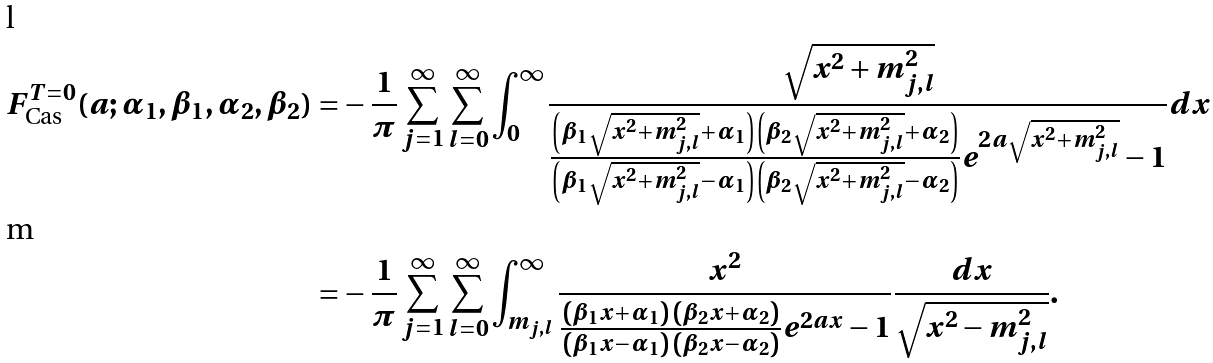Convert formula to latex. <formula><loc_0><loc_0><loc_500><loc_500>F ^ { T = 0 } _ { \text {Cas} } ( a ; \alpha _ { 1 } , \beta _ { 1 } , \alpha _ { 2 } , \beta _ { 2 } ) = & - \frac { 1 } { \pi } \sum _ { j = 1 } ^ { \infty } \sum _ { l = 0 } ^ { \infty } \int _ { 0 } ^ { \infty } \frac { \sqrt { x ^ { 2 } + m _ { j , l } ^ { 2 } } } { \frac { \left ( \beta _ { 1 } \sqrt { x ^ { 2 } + m _ { j , l } ^ { 2 } } + \alpha _ { 1 } \right ) \left ( \beta _ { 2 } \sqrt { x ^ { 2 } + m _ { j , l } ^ { 2 } } + \alpha _ { 2 } \right ) } { \left ( \beta _ { 1 } \sqrt { x ^ { 2 } + m _ { j , l } ^ { 2 } } - \alpha _ { 1 } \right ) \left ( \beta _ { 2 } \sqrt { x ^ { 2 } + m _ { j , l } ^ { 2 } } - \alpha _ { 2 } \right ) } e ^ { 2 a \sqrt { x ^ { 2 } + m _ { j , l } ^ { 2 } } } - 1 } d x \\ = & - \frac { 1 } { \pi } \sum _ { j = 1 } ^ { \infty } \sum _ { l = 0 } ^ { \infty } \int _ { m _ { j , l } } ^ { \infty } \frac { x ^ { 2 } } { \frac { \left ( \beta _ { 1 } x + \alpha _ { 1 } \right ) \left ( \beta _ { 2 } x + \alpha _ { 2 } \right ) } { \left ( \beta _ { 1 } x - \alpha _ { 1 } \right ) \left ( \beta _ { 2 } x - \alpha _ { 2 } \right ) } e ^ { 2 a x } - 1 } \frac { d x } { \sqrt { x ^ { 2 } - m _ { j , l } ^ { 2 } } } .</formula> 